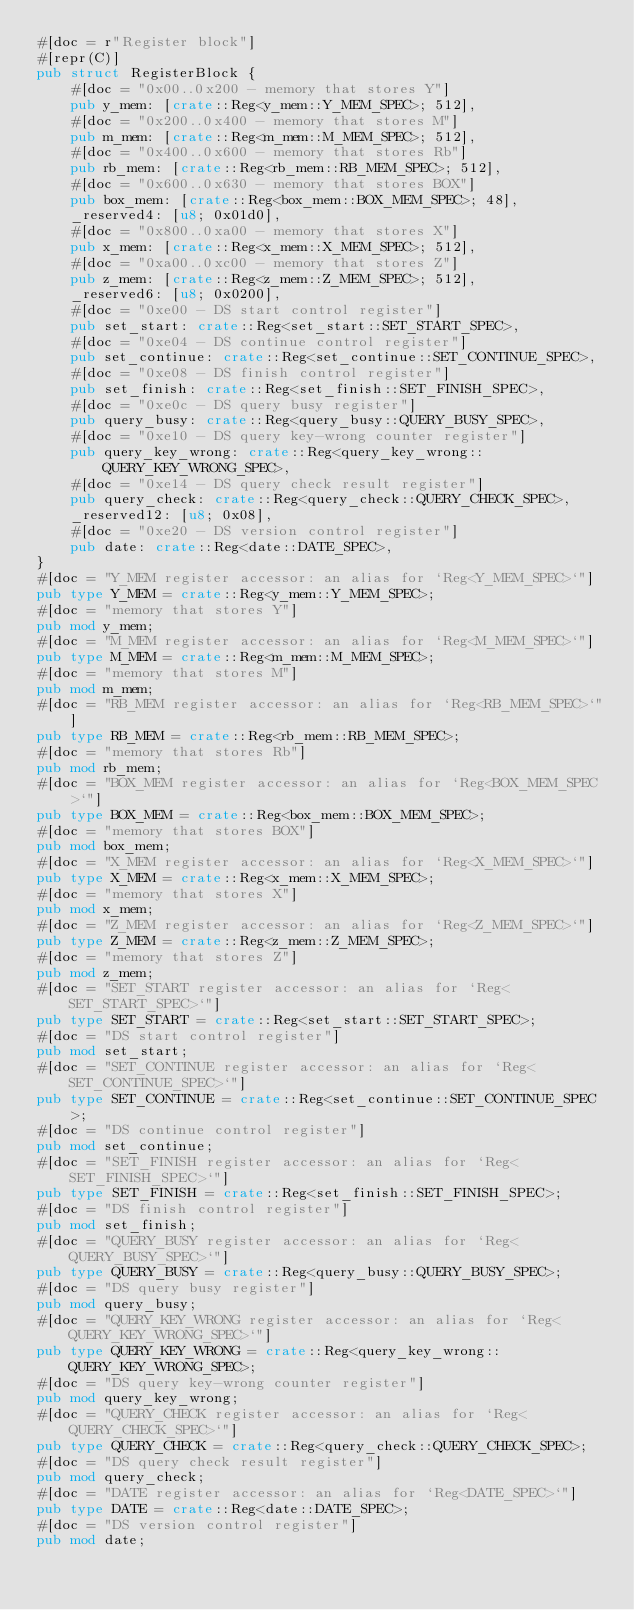Convert code to text. <code><loc_0><loc_0><loc_500><loc_500><_Rust_>#[doc = r"Register block"]
#[repr(C)]
pub struct RegisterBlock {
    #[doc = "0x00..0x200 - memory that stores Y"]
    pub y_mem: [crate::Reg<y_mem::Y_MEM_SPEC>; 512],
    #[doc = "0x200..0x400 - memory that stores M"]
    pub m_mem: [crate::Reg<m_mem::M_MEM_SPEC>; 512],
    #[doc = "0x400..0x600 - memory that stores Rb"]
    pub rb_mem: [crate::Reg<rb_mem::RB_MEM_SPEC>; 512],
    #[doc = "0x600..0x630 - memory that stores BOX"]
    pub box_mem: [crate::Reg<box_mem::BOX_MEM_SPEC>; 48],
    _reserved4: [u8; 0x01d0],
    #[doc = "0x800..0xa00 - memory that stores X"]
    pub x_mem: [crate::Reg<x_mem::X_MEM_SPEC>; 512],
    #[doc = "0xa00..0xc00 - memory that stores Z"]
    pub z_mem: [crate::Reg<z_mem::Z_MEM_SPEC>; 512],
    _reserved6: [u8; 0x0200],
    #[doc = "0xe00 - DS start control register"]
    pub set_start: crate::Reg<set_start::SET_START_SPEC>,
    #[doc = "0xe04 - DS continue control register"]
    pub set_continue: crate::Reg<set_continue::SET_CONTINUE_SPEC>,
    #[doc = "0xe08 - DS finish control register"]
    pub set_finish: crate::Reg<set_finish::SET_FINISH_SPEC>,
    #[doc = "0xe0c - DS query busy register"]
    pub query_busy: crate::Reg<query_busy::QUERY_BUSY_SPEC>,
    #[doc = "0xe10 - DS query key-wrong counter register"]
    pub query_key_wrong: crate::Reg<query_key_wrong::QUERY_KEY_WRONG_SPEC>,
    #[doc = "0xe14 - DS query check result register"]
    pub query_check: crate::Reg<query_check::QUERY_CHECK_SPEC>,
    _reserved12: [u8; 0x08],
    #[doc = "0xe20 - DS version control register"]
    pub date: crate::Reg<date::DATE_SPEC>,
}
#[doc = "Y_MEM register accessor: an alias for `Reg<Y_MEM_SPEC>`"]
pub type Y_MEM = crate::Reg<y_mem::Y_MEM_SPEC>;
#[doc = "memory that stores Y"]
pub mod y_mem;
#[doc = "M_MEM register accessor: an alias for `Reg<M_MEM_SPEC>`"]
pub type M_MEM = crate::Reg<m_mem::M_MEM_SPEC>;
#[doc = "memory that stores M"]
pub mod m_mem;
#[doc = "RB_MEM register accessor: an alias for `Reg<RB_MEM_SPEC>`"]
pub type RB_MEM = crate::Reg<rb_mem::RB_MEM_SPEC>;
#[doc = "memory that stores Rb"]
pub mod rb_mem;
#[doc = "BOX_MEM register accessor: an alias for `Reg<BOX_MEM_SPEC>`"]
pub type BOX_MEM = crate::Reg<box_mem::BOX_MEM_SPEC>;
#[doc = "memory that stores BOX"]
pub mod box_mem;
#[doc = "X_MEM register accessor: an alias for `Reg<X_MEM_SPEC>`"]
pub type X_MEM = crate::Reg<x_mem::X_MEM_SPEC>;
#[doc = "memory that stores X"]
pub mod x_mem;
#[doc = "Z_MEM register accessor: an alias for `Reg<Z_MEM_SPEC>`"]
pub type Z_MEM = crate::Reg<z_mem::Z_MEM_SPEC>;
#[doc = "memory that stores Z"]
pub mod z_mem;
#[doc = "SET_START register accessor: an alias for `Reg<SET_START_SPEC>`"]
pub type SET_START = crate::Reg<set_start::SET_START_SPEC>;
#[doc = "DS start control register"]
pub mod set_start;
#[doc = "SET_CONTINUE register accessor: an alias for `Reg<SET_CONTINUE_SPEC>`"]
pub type SET_CONTINUE = crate::Reg<set_continue::SET_CONTINUE_SPEC>;
#[doc = "DS continue control register"]
pub mod set_continue;
#[doc = "SET_FINISH register accessor: an alias for `Reg<SET_FINISH_SPEC>`"]
pub type SET_FINISH = crate::Reg<set_finish::SET_FINISH_SPEC>;
#[doc = "DS finish control register"]
pub mod set_finish;
#[doc = "QUERY_BUSY register accessor: an alias for `Reg<QUERY_BUSY_SPEC>`"]
pub type QUERY_BUSY = crate::Reg<query_busy::QUERY_BUSY_SPEC>;
#[doc = "DS query busy register"]
pub mod query_busy;
#[doc = "QUERY_KEY_WRONG register accessor: an alias for `Reg<QUERY_KEY_WRONG_SPEC>`"]
pub type QUERY_KEY_WRONG = crate::Reg<query_key_wrong::QUERY_KEY_WRONG_SPEC>;
#[doc = "DS query key-wrong counter register"]
pub mod query_key_wrong;
#[doc = "QUERY_CHECK register accessor: an alias for `Reg<QUERY_CHECK_SPEC>`"]
pub type QUERY_CHECK = crate::Reg<query_check::QUERY_CHECK_SPEC>;
#[doc = "DS query check result register"]
pub mod query_check;
#[doc = "DATE register accessor: an alias for `Reg<DATE_SPEC>`"]
pub type DATE = crate::Reg<date::DATE_SPEC>;
#[doc = "DS version control register"]
pub mod date;
</code> 